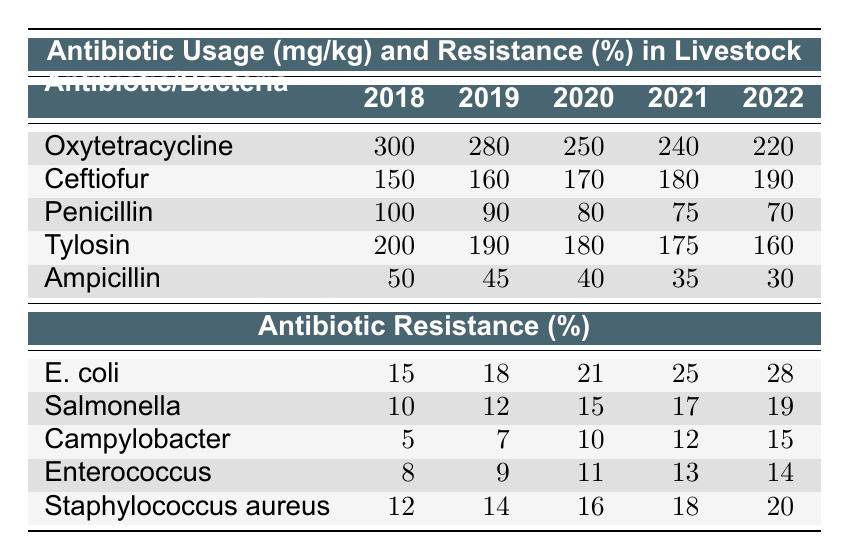What was the antibiotic usage of Penicillin in 2020? In the table under the section for antibiotic usage, the value for Penicillin in the year 2020 is directly listed as 80 mg/kg.
Answer: 80 mg/kg What is the trend of Ceftiofur usage from 2018 to 2022? By looking at the values in the Ceftiofur row, we see an increase from 150 mg/kg in 2018 to 190 mg/kg in 2022, indicating a consistent upward trend over the years.
Answer: Increasing What is the total antibiotic usage for Ampicillin over the years 2018 to 2022? To find the total, we add the values for Ampicillin across the years: 50 + 45 + 40 + 35 + 30 = 200 mg/kg.
Answer: 200 mg/kg Is there an increase or decrease in the resistance percentage of E. coli from 2018 to 2022? The resistance percentage for E. coli starts at 15% in 2018 and rises to 28% in 2022, indicating a significant increase over the years.
Answer: Increase What is the average resistance percentage of Salmonella from 2018 to 2022? We sum the resistance percentages for Salmonella: 10 + 12 + 15 + 17 + 19 = 73, then divide by 5 to find the average: 73/5 = 14.6%.
Answer: 14.6% What was the antibiotic usage of Tylosin in 2021? The table indicates that Tylosin usage in 2021 is 175 mg/kg, which is directly read from the respective row for Tylosin under the year 2021.
Answer: 175 mg/kg In which year did Campylobacter show the highest resistance percentage? Looking at the values for Campylobacter, we see that the percentage increases each year, with the highest value of 15% recorded in 2022.
Answer: 2022 Did the usage of Oxytetracycline ever drop below 250 mg/kg between 2018 and 2022? Reviewing the data for Oxytetracycline, it starts at 300 mg/kg and drops below 250 mg/kg only in 2021 (240 mg/kg) and 2022 (220 mg/kg). Therefore, the answer is yes, it did drop below 250 mg/kg.
Answer: Yes What is the difference in resistance percentages between Staphylococcus aureus in 2018 and 2022? For Staphylococcus aureus, the resistance percentage in 2018 was 12%, and in 2022 it was 20%. The difference is 20 - 12 = 8%.
Answer: 8% 